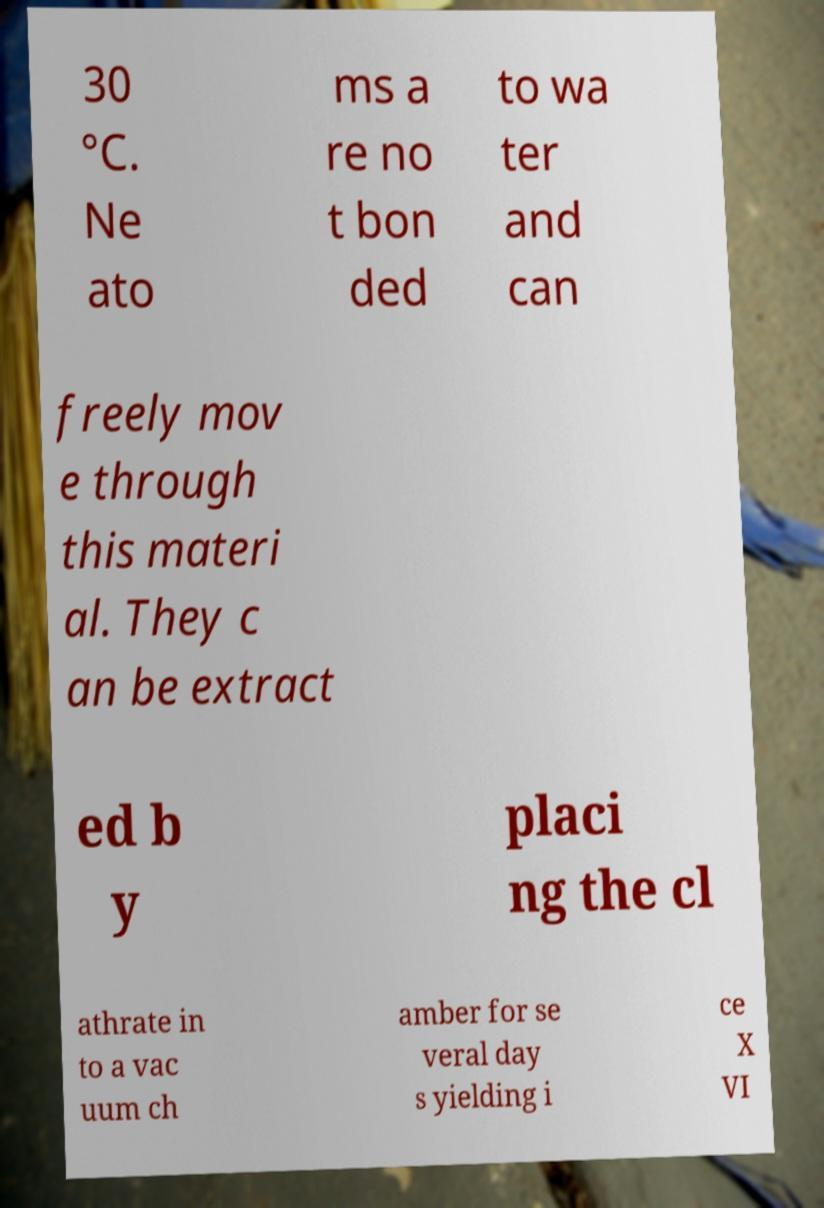Could you extract and type out the text from this image? 30 °C. Ne ato ms a re no t bon ded to wa ter and can freely mov e through this materi al. They c an be extract ed b y placi ng the cl athrate in to a vac uum ch amber for se veral day s yielding i ce X VI 